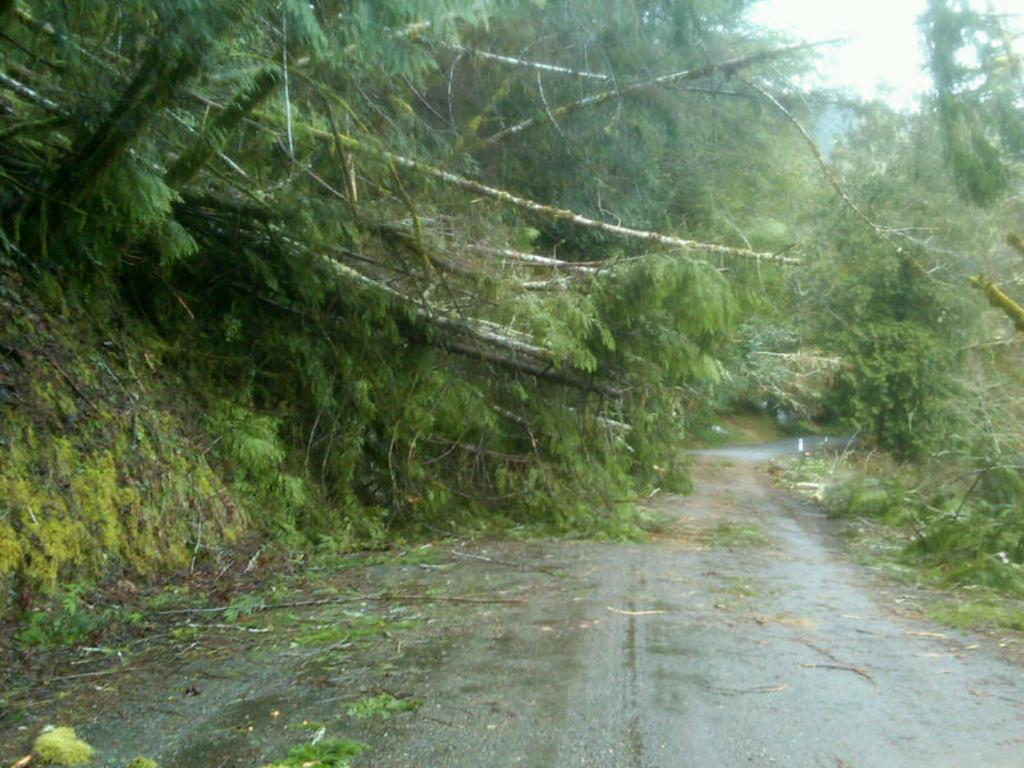What type of vegetation can be seen in the image? There are trees and plants in the image. What man-made structure is visible in the image? There is a road in the image. What part of the natural environment is visible in the image? The sky is visible in the image. Can you see any boats in the image? There are no boats present in the image. What type of nail is being used to hold the trees together in the image? There are no nails visible in the image, and trees are not held together by nails. 